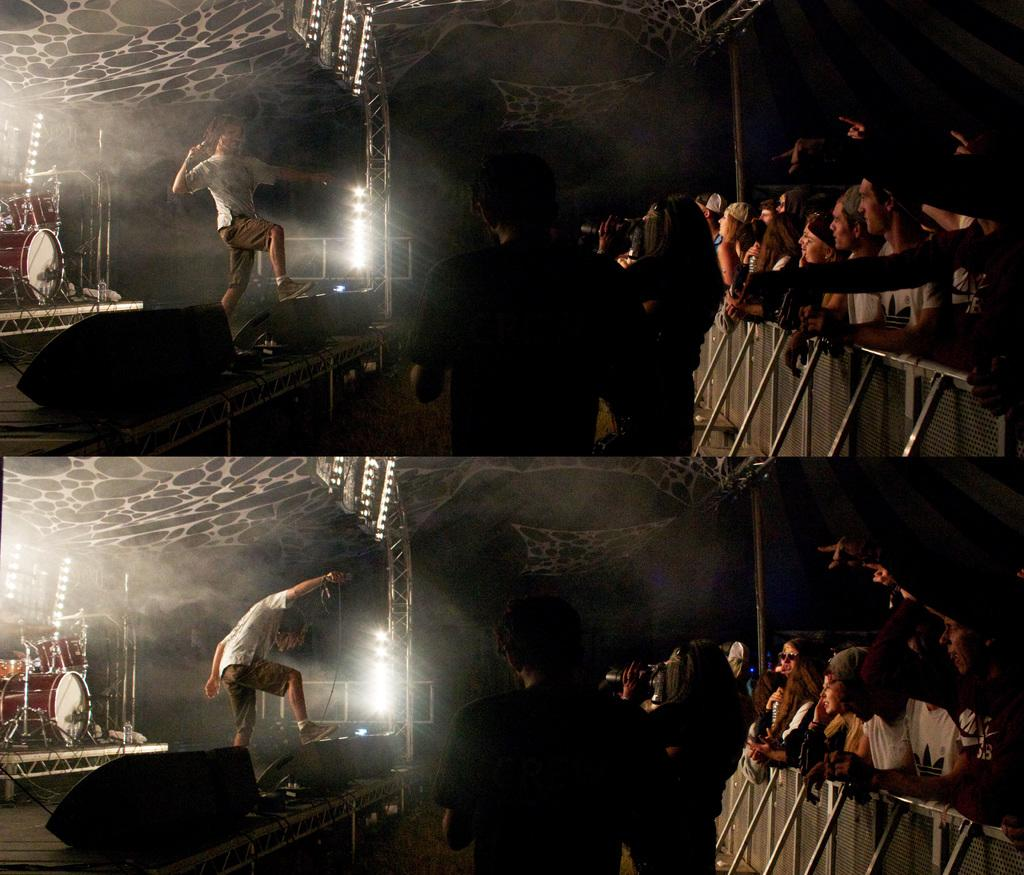What is the person in the image doing? The person is singing in the image. What is the person holding while singing? The person is holding a microphone. Are there other people in the image besides the person singing? Yes, there are other people present in the image. What else is the person holding besides the microphone? The person is also holding a camera. What else can be seen in the image related to music? Musical instruments are visible in the image. What else can be seen in the image related to lighting? Lights are present in the image. How many jellyfish are swimming in the background of the image? There are no jellyfish present in the image; it features a person singing with musical instruments and lights. What type of geese can be seen interacting with the person holding the microphone? There are no geese present in the image; it features a person singing with musical instruments and lights. 